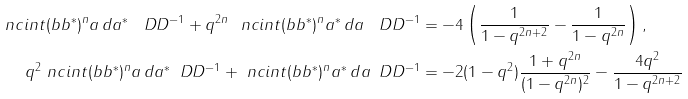<formula> <loc_0><loc_0><loc_500><loc_500>\ n c i n t ( b b ^ { * } ) ^ { n } a \, d a ^ { * } \, \ D D ^ { - 1 } + q ^ { 2 n } \ n c i n t ( b b ^ { * } ) ^ { n } a ^ { * } \, d a \, \ D D ^ { - 1 } & = - 4 \left ( \frac { 1 } { 1 - q ^ { 2 n + 2 } } - \frac { 1 } { 1 - q ^ { 2 n } } \right ) , \\ q ^ { 2 } \ n c i n t ( b b ^ { * } ) ^ { n } a \, d a ^ { * } \, \ D D ^ { - 1 } + \ n c i n t ( b b ^ { * } ) ^ { n } a ^ { * } \, d a \, \ D D ^ { - 1 } & = - 2 ( 1 - q ^ { 2 } ) \frac { 1 + q ^ { 2 n } } { ( 1 - q ^ { 2 n } ) ^ { 2 } } - \frac { 4 q ^ { 2 } } { 1 - q ^ { 2 n + 2 } }</formula> 